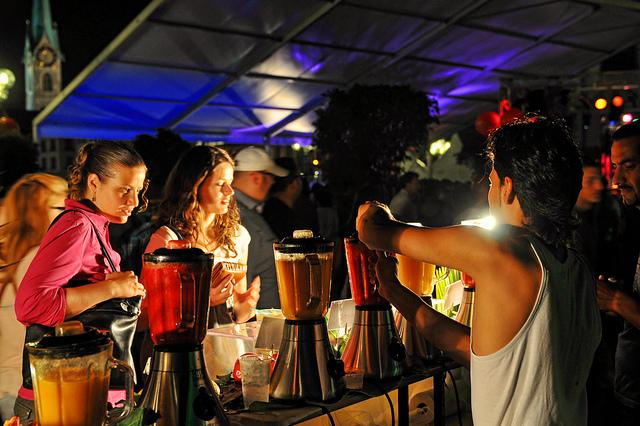What is the boy doing? Please explain your reasoning. selling juice. Given the time of day, or rather night, it's most likely a as smoothies. the other options don't fit well. 